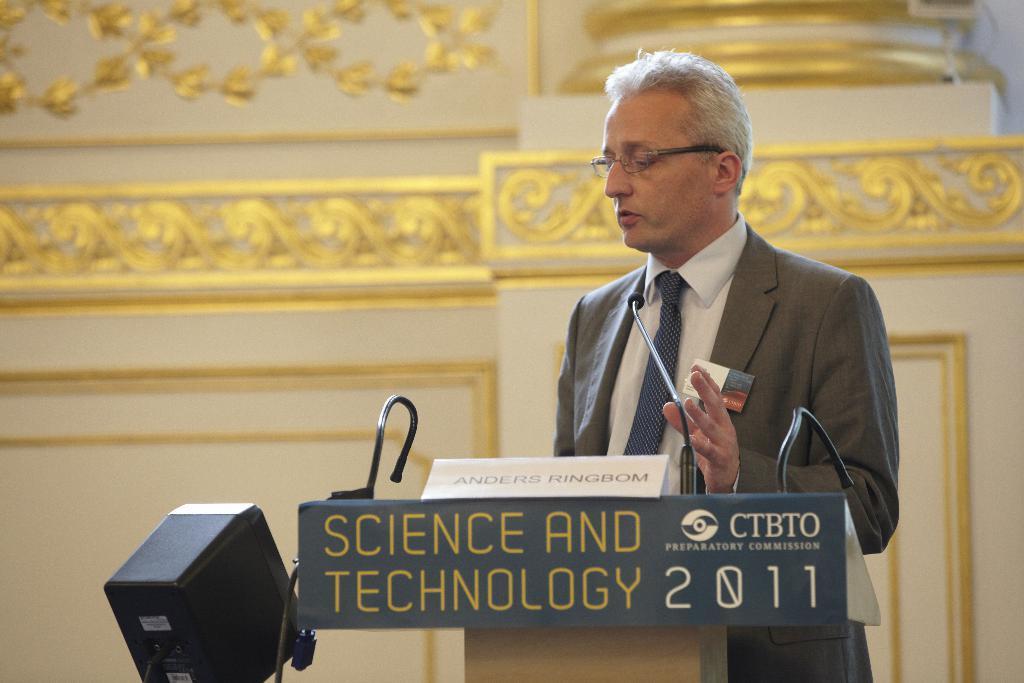Can you describe this image briefly? In this image there is a person standing on the dais is speaking in front of a mic, on the dais there is his name plate and some text written, beside the person there is an electronic device, behind the person there is a wall. 